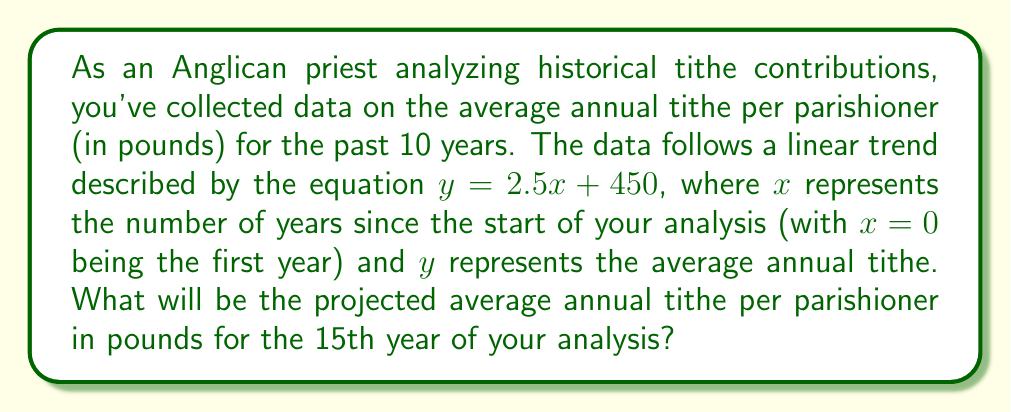Can you solve this math problem? To solve this problem, we'll use the given linear regression equation and follow these steps:

1. Identify the linear equation: $y = 2.5x + 450$
   Where $y$ is the average annual tithe in pounds, and $x$ is the number of years since the start of the analysis.

2. Determine the value of $x$ for the 15th year:
   The 15th year corresponds to $x = 14$ (since the first year is $x = 0$)

3. Substitute $x = 14$ into the equation:
   $y = 2.5(14) + 450$

4. Calculate the result:
   $y = 35 + 450 = 485$

Therefore, the projected average annual tithe per parishioner for the 15th year will be 485 pounds.
Answer: $485$ pounds 